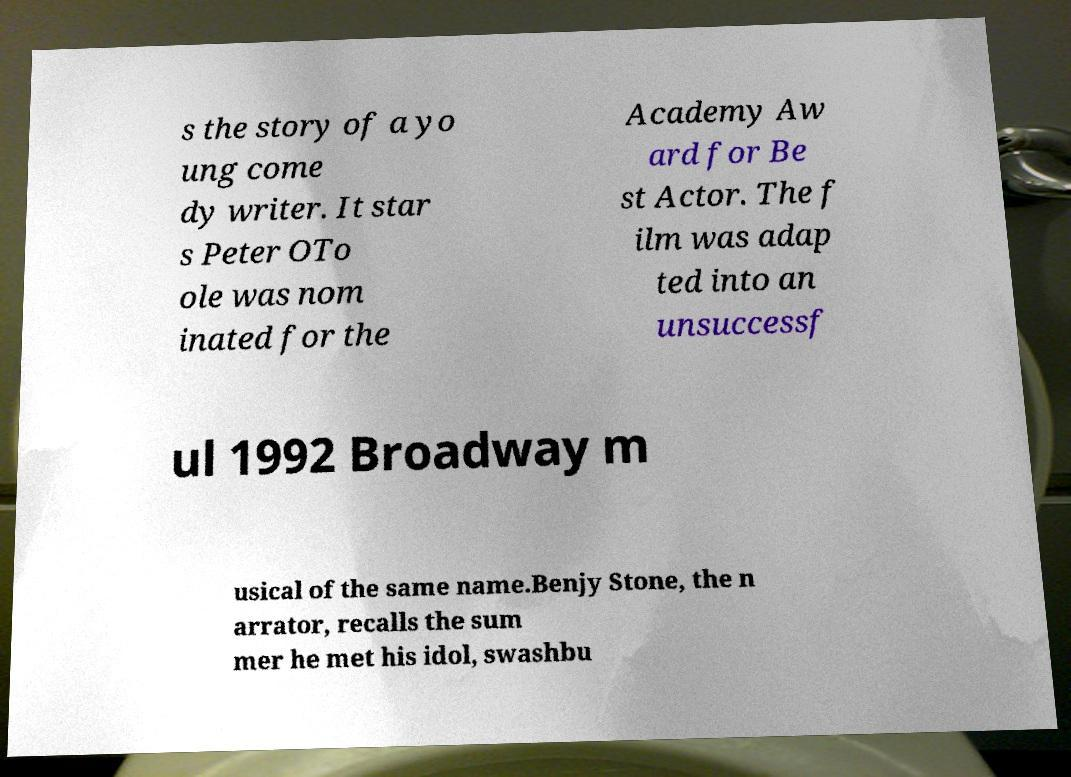I need the written content from this picture converted into text. Can you do that? s the story of a yo ung come dy writer. It star s Peter OTo ole was nom inated for the Academy Aw ard for Be st Actor. The f ilm was adap ted into an unsuccessf ul 1992 Broadway m usical of the same name.Benjy Stone, the n arrator, recalls the sum mer he met his idol, swashbu 